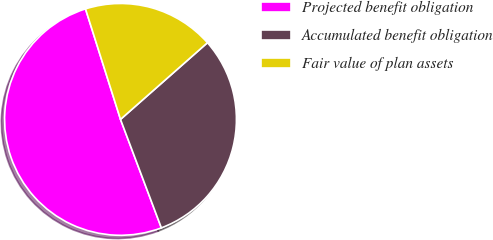Convert chart. <chart><loc_0><loc_0><loc_500><loc_500><pie_chart><fcel>Projected benefit obligation<fcel>Accumulated benefit obligation<fcel>Fair value of plan assets<nl><fcel>50.85%<fcel>30.77%<fcel>18.38%<nl></chart> 